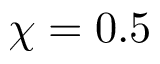<formula> <loc_0><loc_0><loc_500><loc_500>\chi = 0 . 5</formula> 